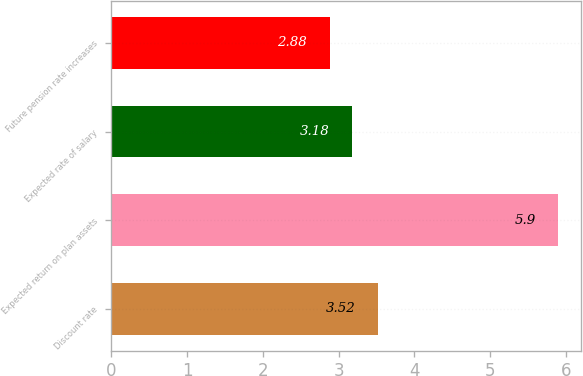<chart> <loc_0><loc_0><loc_500><loc_500><bar_chart><fcel>Discount rate<fcel>Expected return on plan assets<fcel>Expected rate of salary<fcel>Future pension rate increases<nl><fcel>3.52<fcel>5.9<fcel>3.18<fcel>2.88<nl></chart> 